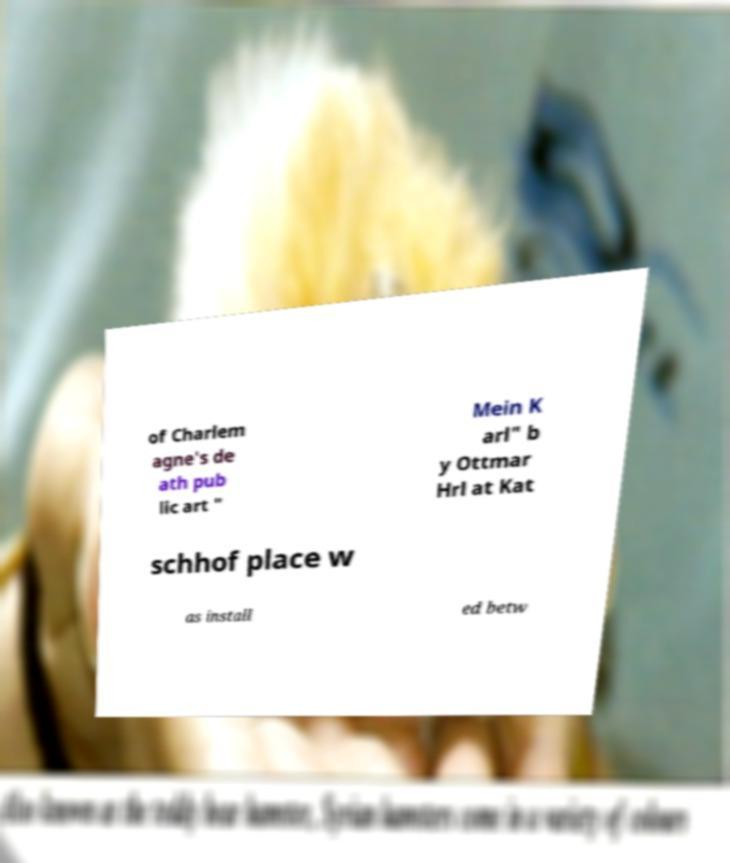What messages or text are displayed in this image? I need them in a readable, typed format. of Charlem agne's de ath pub lic art " Mein K arl" b y Ottmar Hrl at Kat schhof place w as install ed betw 